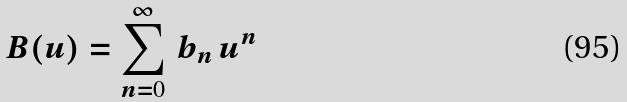<formula> <loc_0><loc_0><loc_500><loc_500>B ( u ) = \sum _ { n = 0 } ^ { \infty } \, b _ { n } \, u ^ { n } \,</formula> 